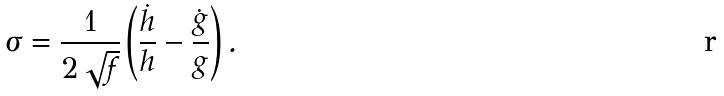Convert formula to latex. <formula><loc_0><loc_0><loc_500><loc_500>\sigma = \frac { 1 } { 2 \sqrt { f } } \left ( \frac { \dot { h } } { h } - \frac { \dot { g } } { g } \right ) .</formula> 